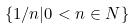<formula> <loc_0><loc_0><loc_500><loc_500>\{ 1 / n | 0 < n \in N \}</formula> 